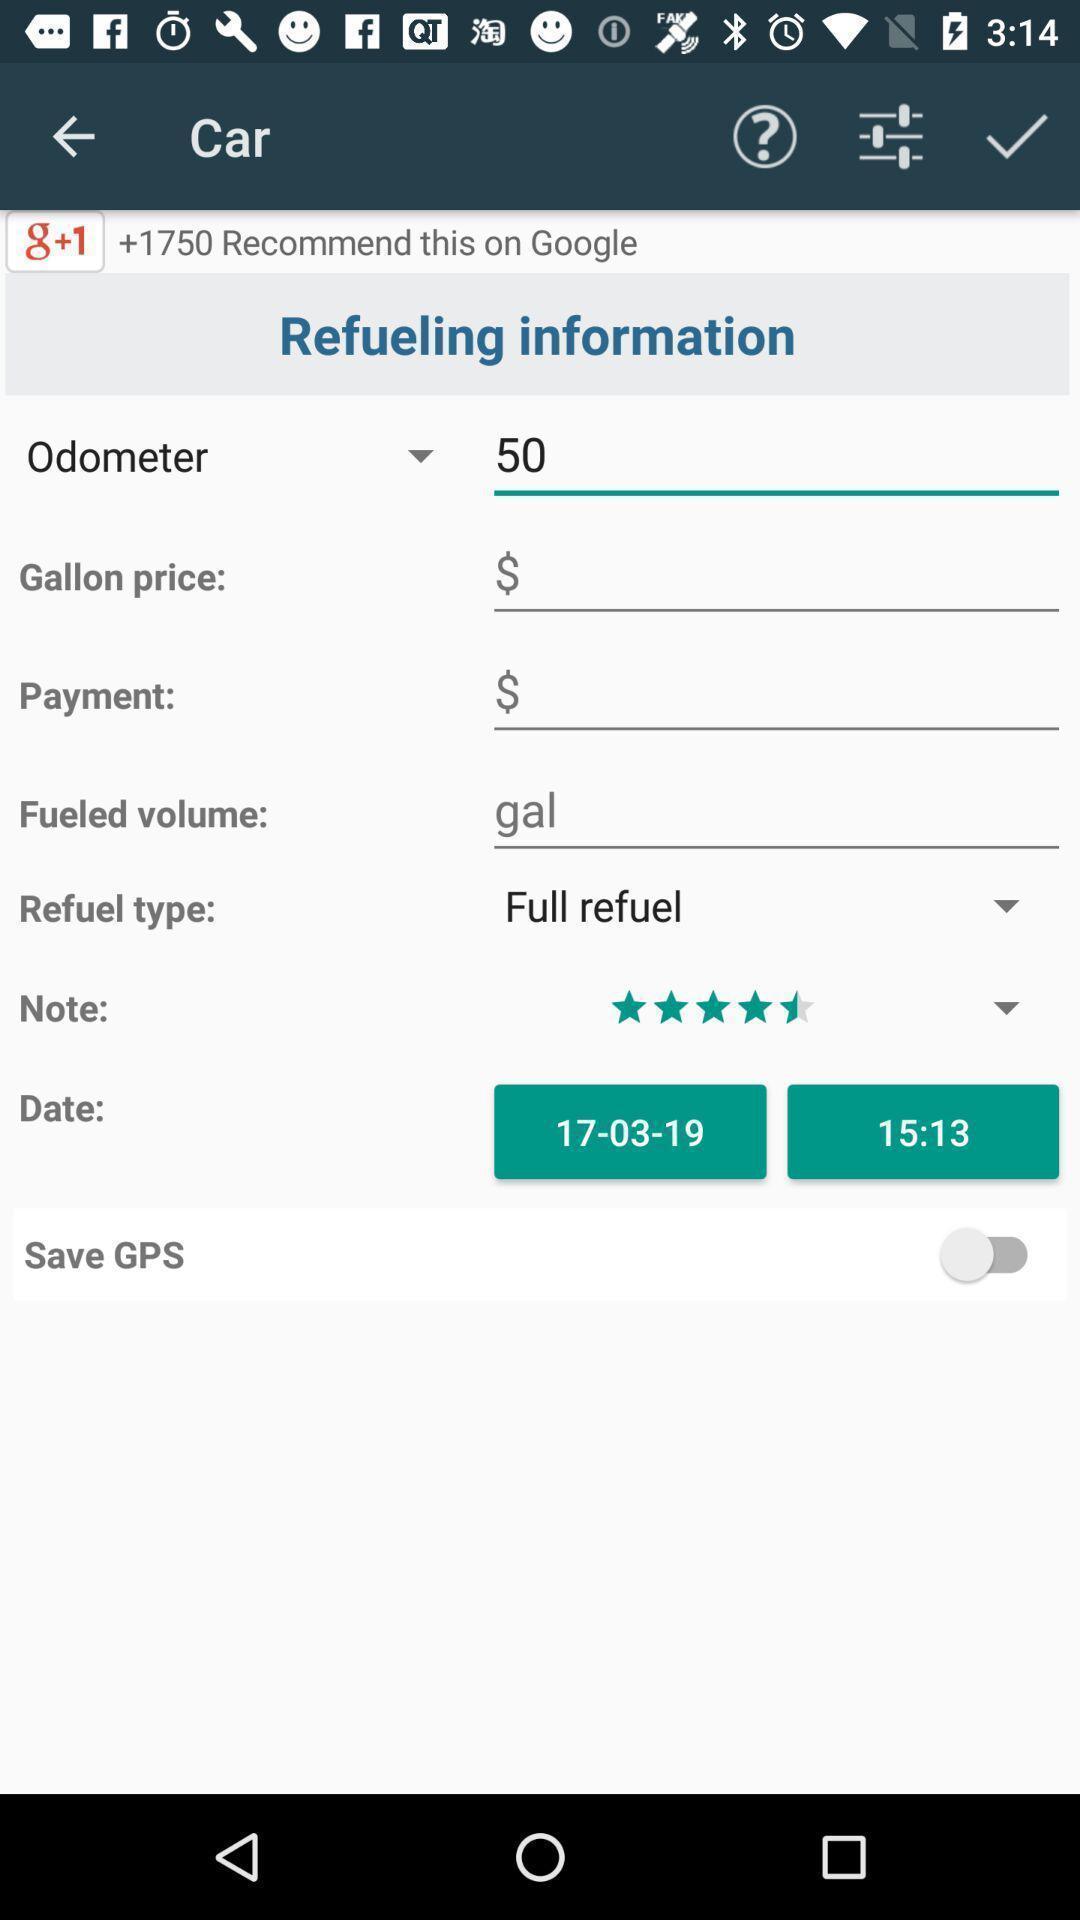What can you discern from this picture? Screen showing vehicle refueling information. 